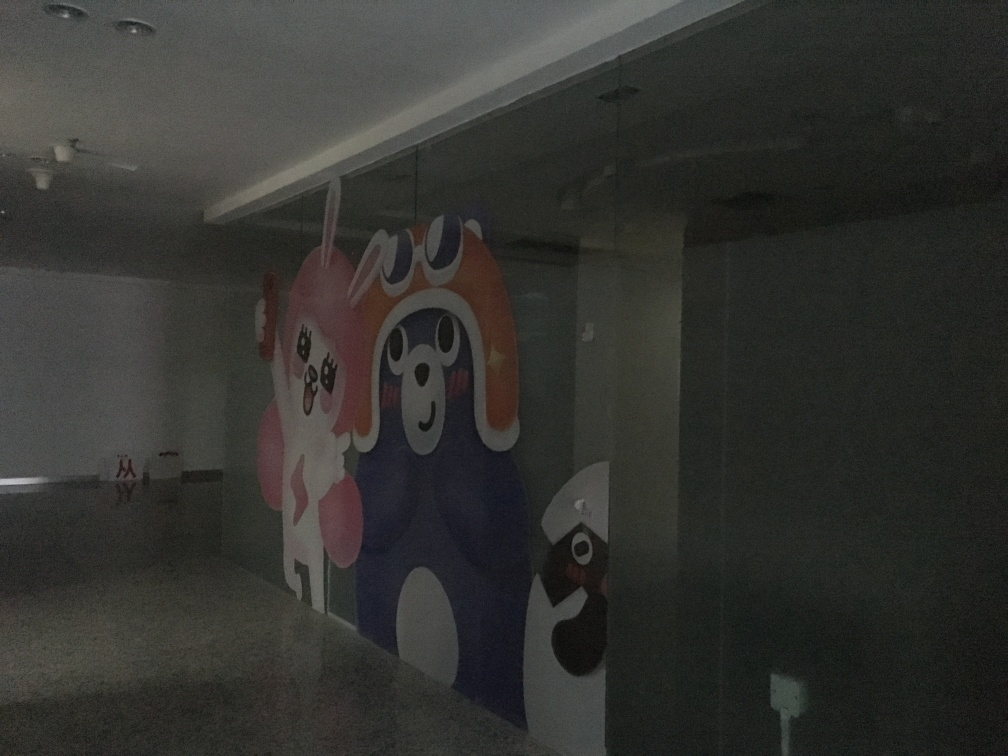What type of location does this image depict, and what are the objects we're seeing on the walls? This image seems to depict an indoor area, likely a public or commercial space given the style of the mural on the walls. What you are seeing appears to be a colorful wall art installation or mural that includes cartoon-like characters. These kinds of murals are often found in places seeking to create a vibrant and playful atmosphere. Could you suggest how the lighting could be improved in this space? Certainly! To enhance the lighting, one could consider adding more ceiling fixtures with brighter LED bulbs for a uniform light spread. Additionally, spotlighting could be used to highlight the mural, drawing attention to various elements of the artwork and creating a focal point in the room. 